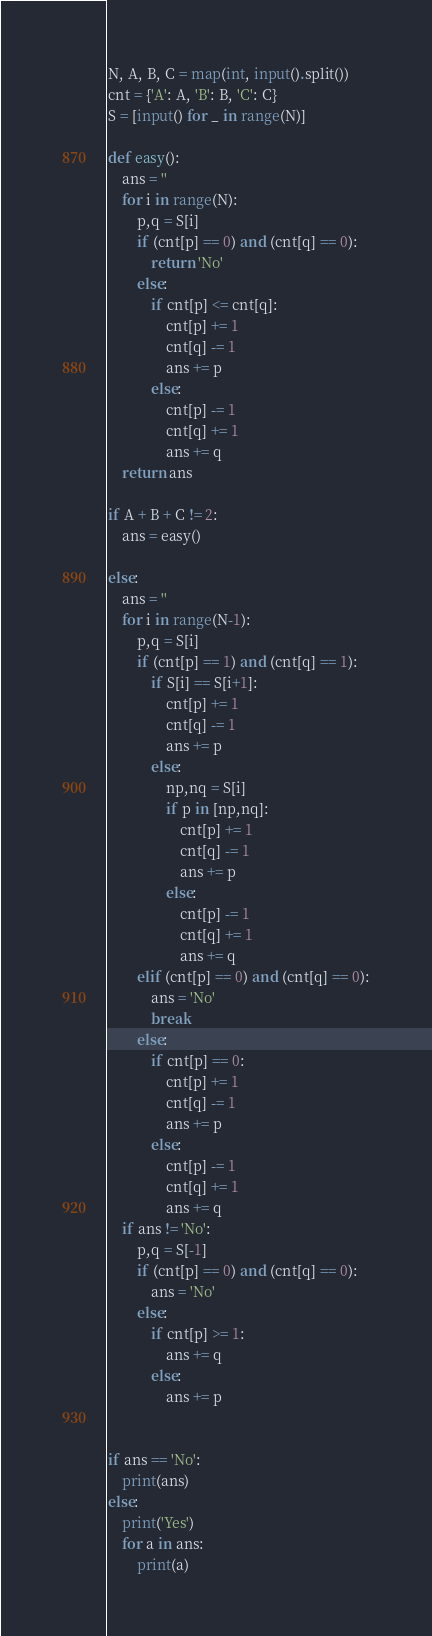Convert code to text. <code><loc_0><loc_0><loc_500><loc_500><_Python_>N, A, B, C = map(int, input().split())
cnt = {'A': A, 'B': B, 'C': C}
S = [input() for _ in range(N)]

def easy():
	ans = ''
	for i in range(N):
		p,q = S[i]
		if (cnt[p] == 0) and (cnt[q] == 0):
			return 'No'
		else:
			if cnt[p] <= cnt[q]:
				cnt[p] += 1
				cnt[q] -= 1
				ans += p
			else:
				cnt[p] -= 1
				cnt[q] += 1
				ans += q
	return ans 

if A + B + C != 2:
    ans = easy()

else:
	ans = ''
	for i in range(N-1):
		p,q = S[i]
		if (cnt[p] == 1) and (cnt[q] == 1):
			if S[i] == S[i+1]:
				cnt[p] += 1
				cnt[q] -= 1
				ans += p
			else:
				np,nq = S[i]
				if p in [np,nq]:
					cnt[p] += 1
					cnt[q] -= 1
					ans += p
				else:
					cnt[p] -= 1
					cnt[q] += 1
					ans += q
		elif (cnt[p] == 0) and (cnt[q] == 0):
			ans = 'No'
			break
		else:
			if cnt[p] == 0:
				cnt[p] += 1
				cnt[q] -= 1
				ans += p
			else:
				cnt[p] -= 1
				cnt[q] += 1
				ans += q
	if ans != 'No':
		p,q = S[-1]
		if (cnt[p] == 0) and (cnt[q] == 0):
			ans = 'No'
		else:
			if cnt[p] >= 1:
				ans += q
			else:
				ans += p


if ans == 'No':
    print(ans)
else:
    print('Yes')
    for a in ans:
        print(a)</code> 